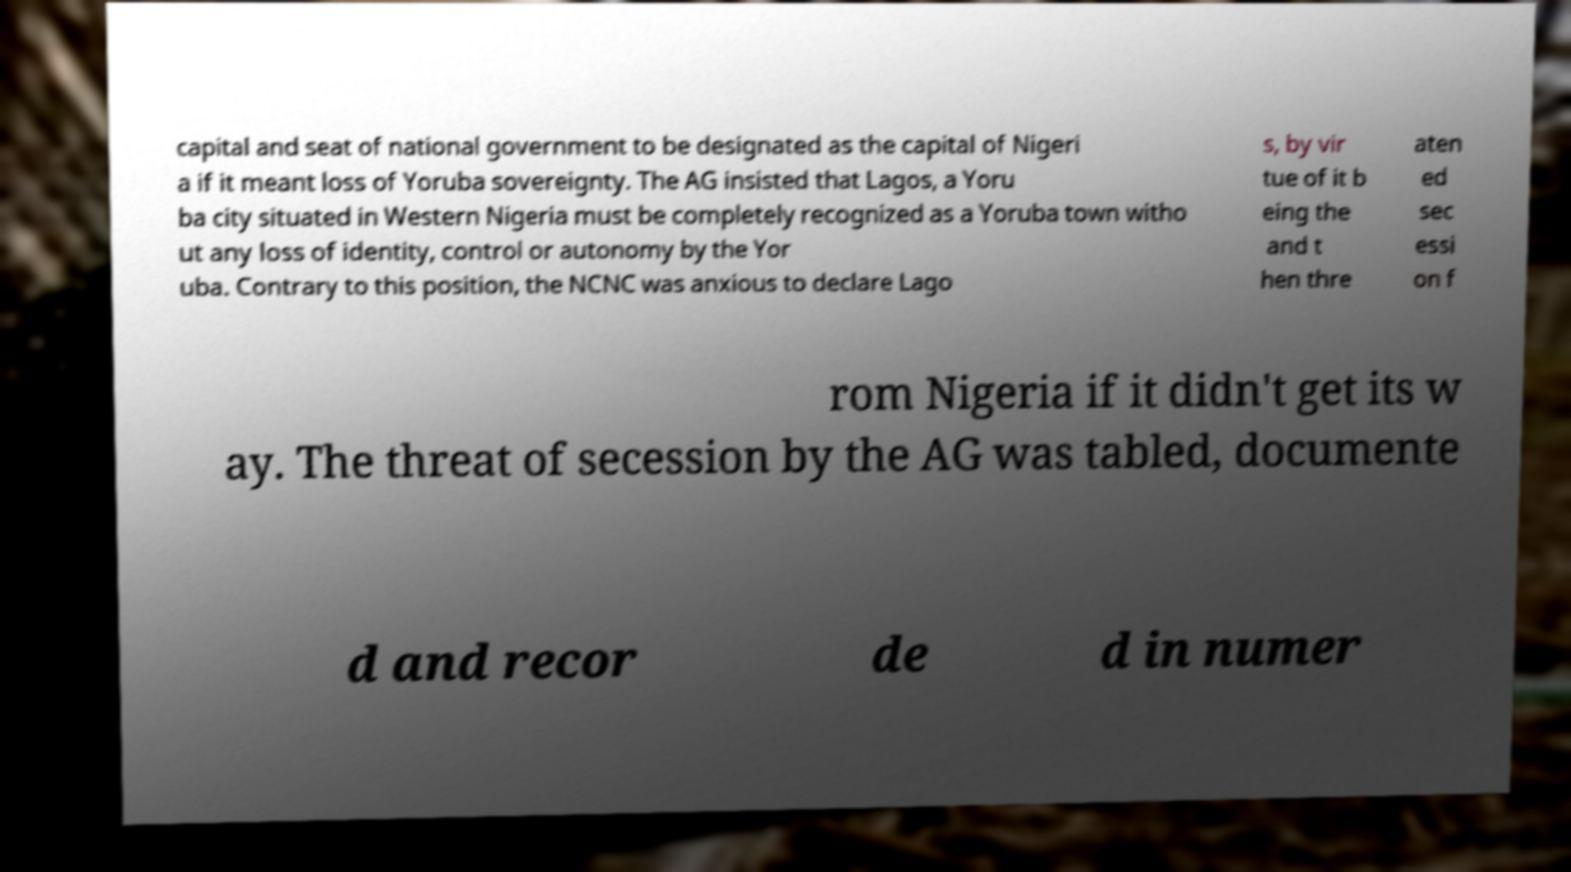Could you extract and type out the text from this image? capital and seat of national government to be designated as the capital of Nigeri a if it meant loss of Yoruba sovereignty. The AG insisted that Lagos, a Yoru ba city situated in Western Nigeria must be completely recognized as a Yoruba town witho ut any loss of identity, control or autonomy by the Yor uba. Contrary to this position, the NCNC was anxious to declare Lago s, by vir tue of it b eing the and t hen thre aten ed sec essi on f rom Nigeria if it didn't get its w ay. The threat of secession by the AG was tabled, documente d and recor de d in numer 